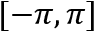<formula> <loc_0><loc_0><loc_500><loc_500>[ - \pi , \pi ]</formula> 